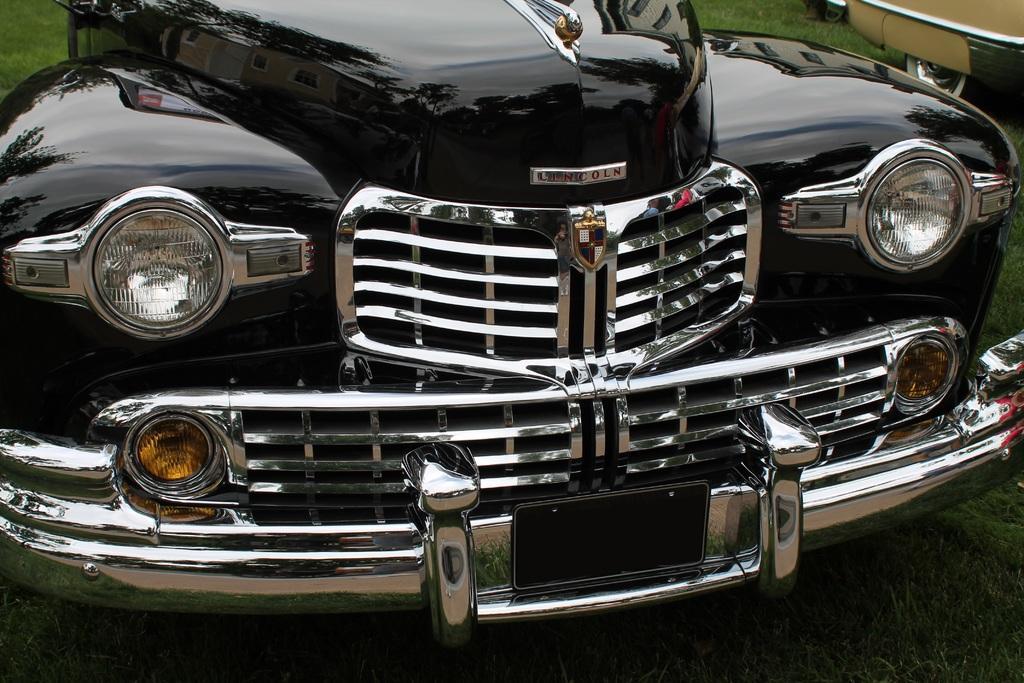In one or two sentences, can you explain what this image depicts? In this picture there is a car in the center of the image, which is black in color and there is grassland at the bottom side of the image, there is another car in the top right side of the image. 